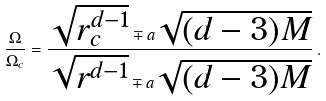<formula> <loc_0><loc_0><loc_500><loc_500>\frac { \Omega } { \Omega _ { c } } = \frac { \sqrt { r _ { c } ^ { d - 1 } } \mp a \sqrt { ( d - 3 ) M } } { \sqrt { r ^ { d - 1 } } \mp a \sqrt { ( d - 3 ) M } } \, .</formula> 